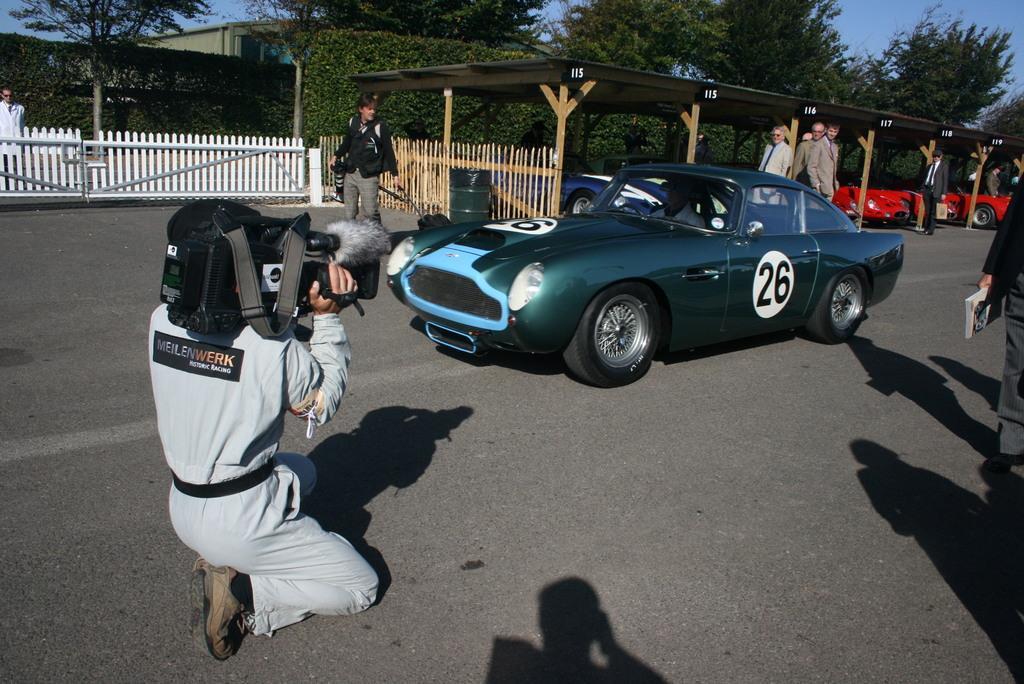Can you describe this image briefly? This picture shows a man holding a video camera in his hand and we see a car on the road and few people are standing. we see a man holding a book in his hand and we see trees buildings and a wooden fence and few cars parked and a blue sky 